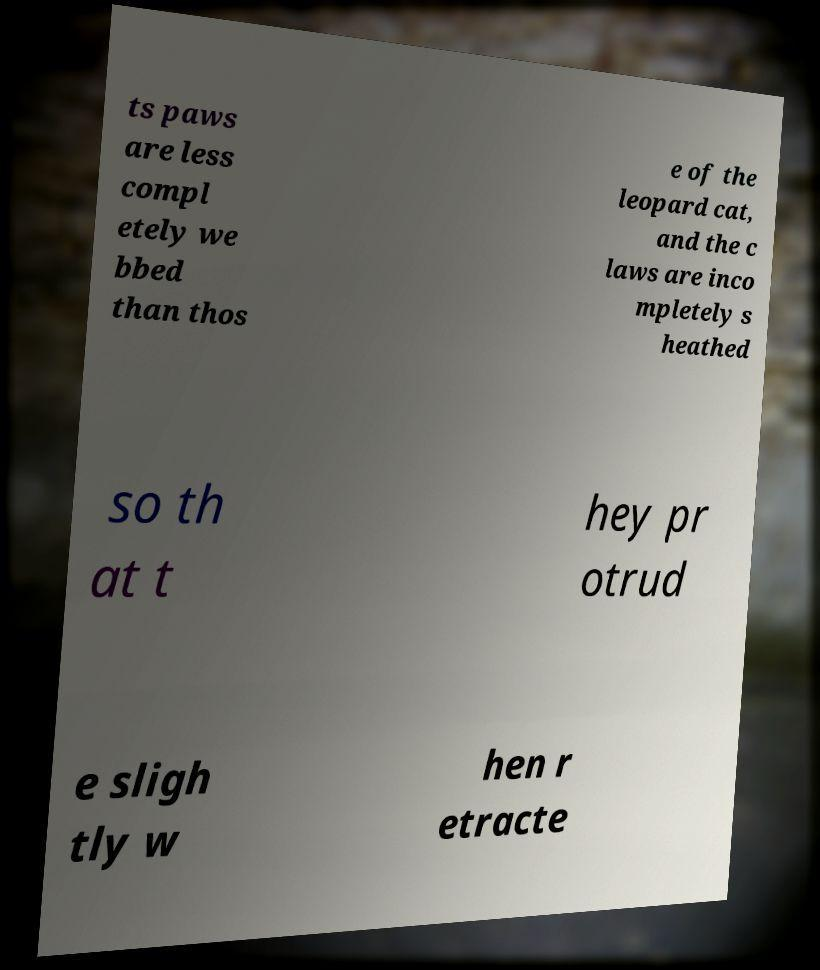There's text embedded in this image that I need extracted. Can you transcribe it verbatim? ts paws are less compl etely we bbed than thos e of the leopard cat, and the c laws are inco mpletely s heathed so th at t hey pr otrud e sligh tly w hen r etracte 